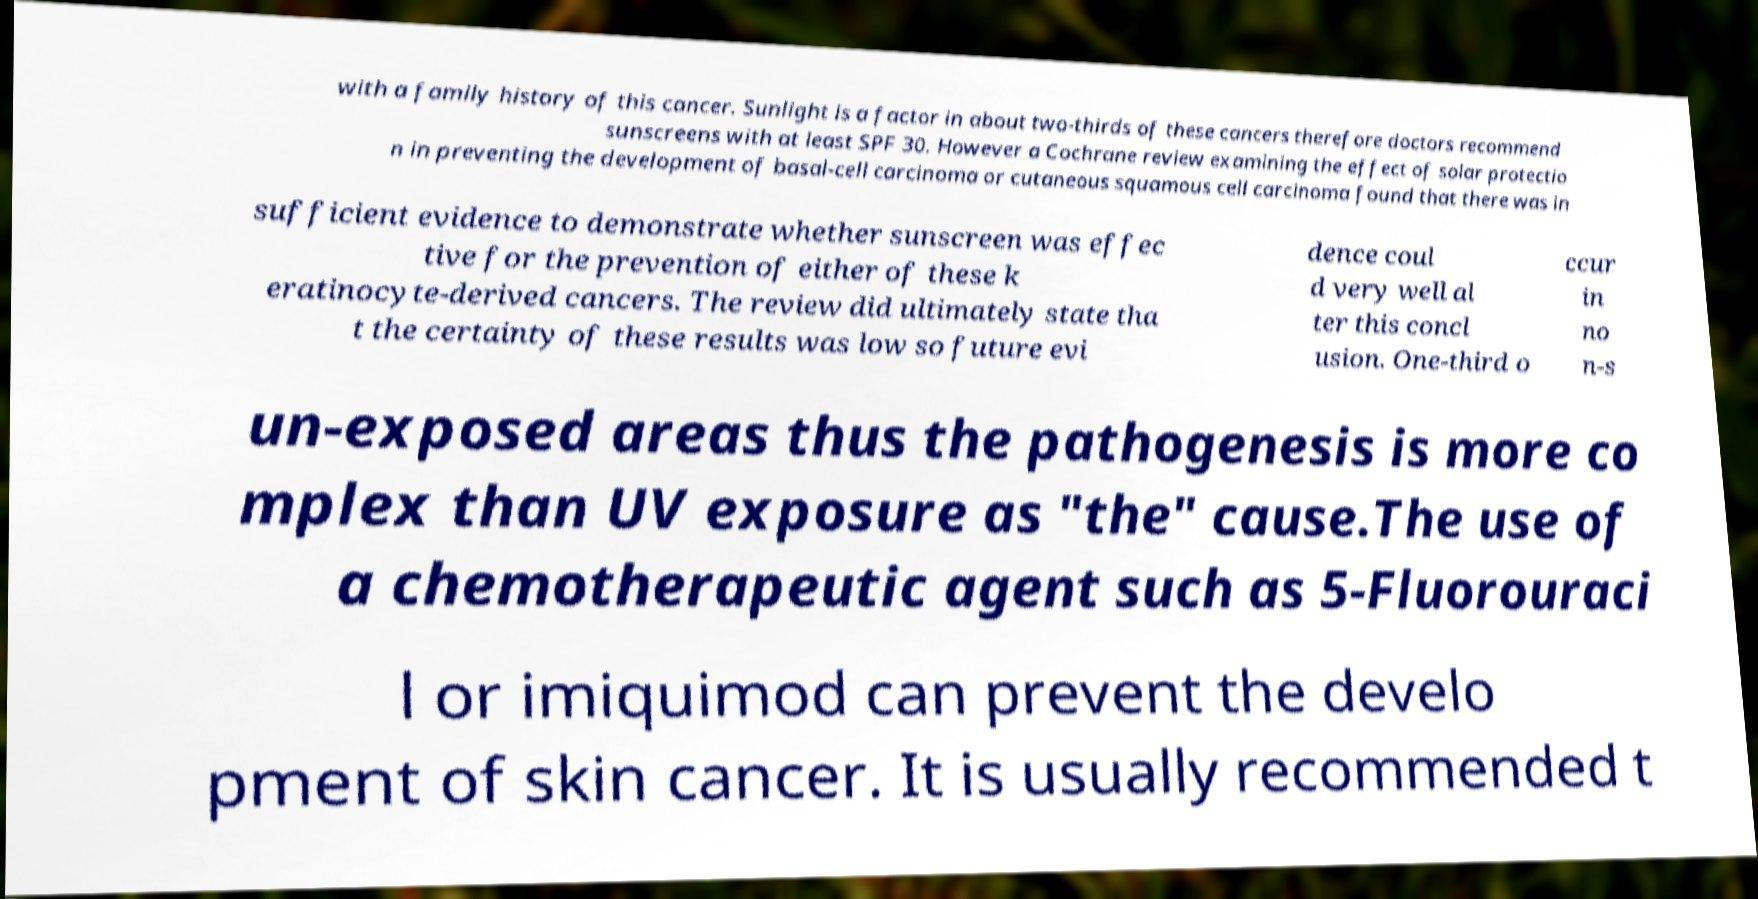Can you accurately transcribe the text from the provided image for me? with a family history of this cancer. Sunlight is a factor in about two-thirds of these cancers therefore doctors recommend sunscreens with at least SPF 30. However a Cochrane review examining the effect of solar protectio n in preventing the development of basal-cell carcinoma or cutaneous squamous cell carcinoma found that there was in sufficient evidence to demonstrate whether sunscreen was effec tive for the prevention of either of these k eratinocyte-derived cancers. The review did ultimately state tha t the certainty of these results was low so future evi dence coul d very well al ter this concl usion. One-third o ccur in no n-s un-exposed areas thus the pathogenesis is more co mplex than UV exposure as "the" cause.The use of a chemotherapeutic agent such as 5-Fluorouraci l or imiquimod can prevent the develo pment of skin cancer. It is usually recommended t 